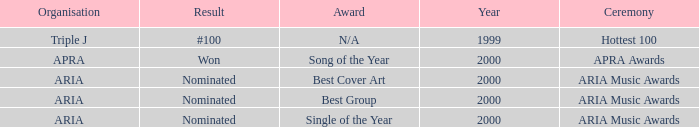Which award was nominated for in 2000? Best Cover Art, Best Group, Single of the Year. 